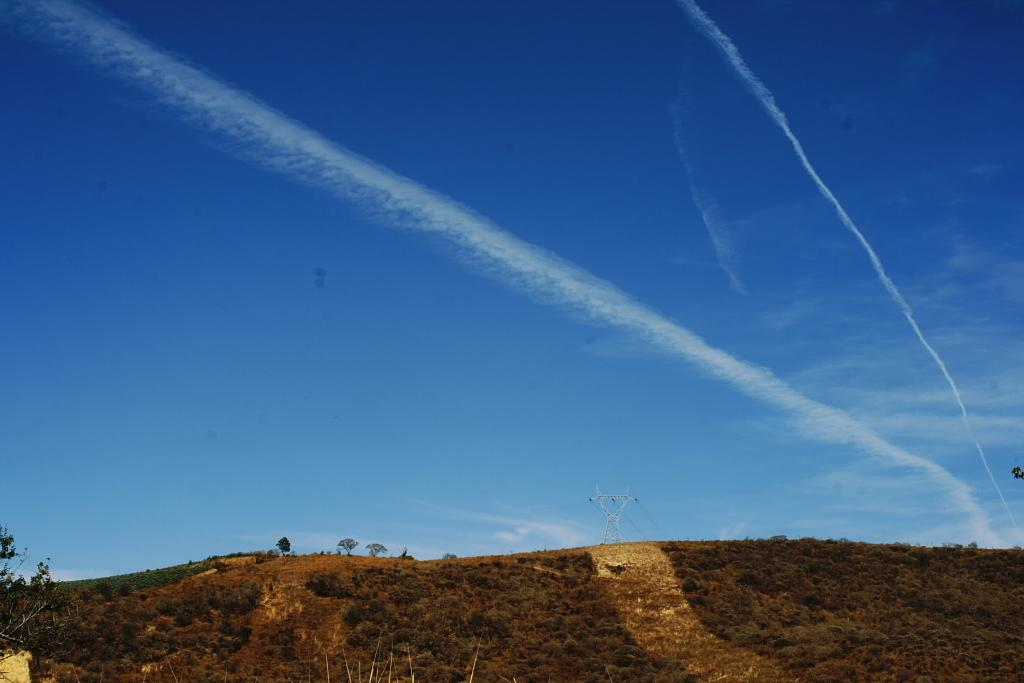What type of vegetation is at the bottom of the image? There are trees at the bottom of the image. What structure can be seen in the middle of the image? There is an electric tower in the middle of the image. What is visible at the top of the image? The sky is visible at the top of the image. What type of test is being conducted in the image? There is no indication of a test being conducted in the image. What sign can be seen on the electric tower? There is no sign visible on the electric tower in the image. 